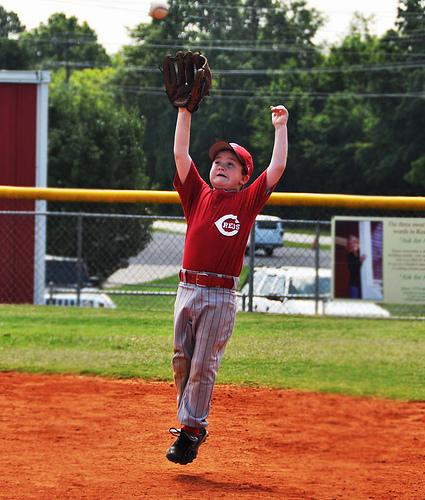What is the outcome if the ball went over the fence?

Choices:
A) hit
B) walk
C) out
D) home run home run 